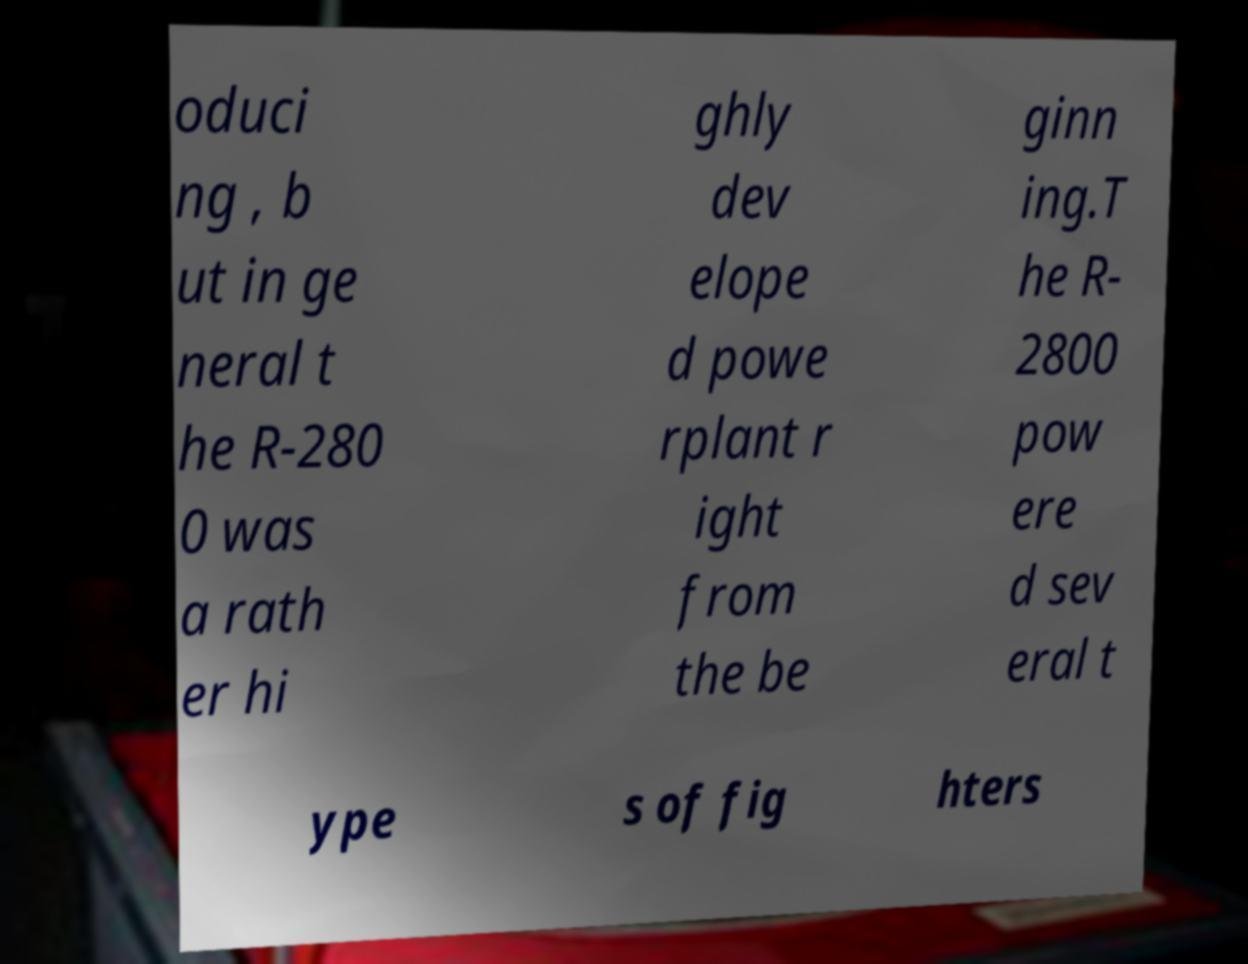Please identify and transcribe the text found in this image. oduci ng , b ut in ge neral t he R-280 0 was a rath er hi ghly dev elope d powe rplant r ight from the be ginn ing.T he R- 2800 pow ere d sev eral t ype s of fig hters 